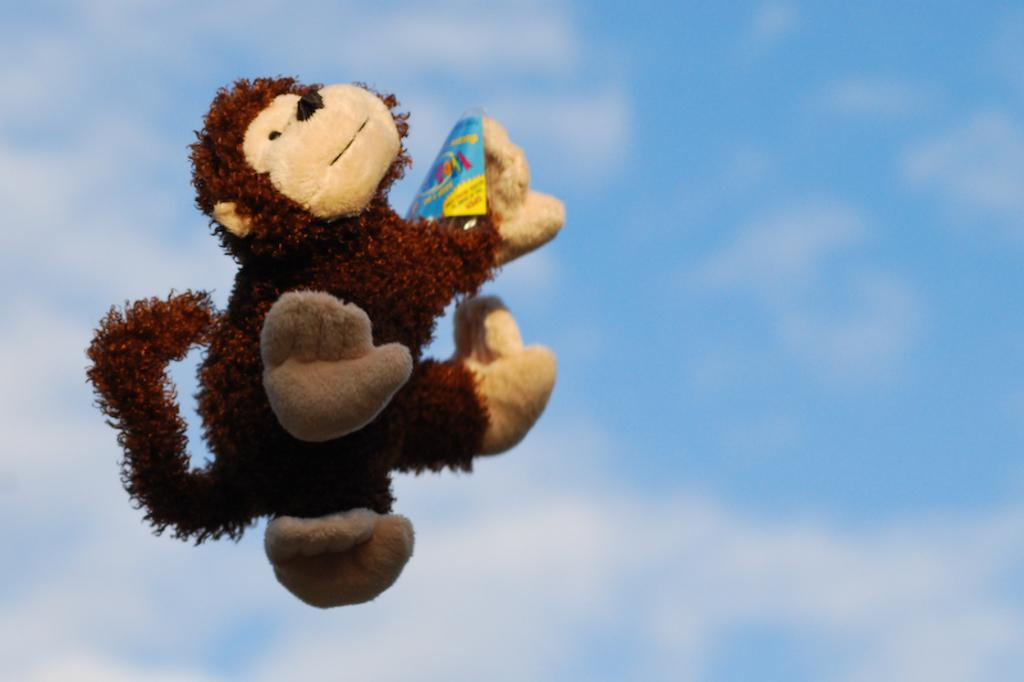What type of toy is in the image? There is a monkey toy in the image. How is the monkey toy positioned in the image? The monkey toy is in the air. What other items can be seen in the image besides the monkey toy? There are colorful objects in the image. What can be seen in the background of the image? The sky is visible in the background of the image. What type of trousers is the monkey wearing in the image? The monkey toy in the image is not a real monkey, so it does not wear trousers. --- Facts: 1. There is a person holding a book in the image. 2. The book has a red cover. 3. The person is sitting on a chair. 4. There is a table in front of the person. 5. The table has a lamp on it. Absurd Topics: elephant, ocean, parade Conversation: What is the person in the image holding? The person in the image is holding a book. What color is the book's cover? The book has a red cover. Where is the person sitting in the image? The person is sitting on a chair. What is in front of the person? There is a table in front of the person. What is on the table? The table has a lamp on it. Reasoning: Let's think step by step in order to produce the conversation. We start by identifying the main subject in the image, which is the person holding a book. Then, we describe the book's cover color and the person's position. Next, we mention the presence of a table and its contents. Each question is designed to elicit a specific detail about the image that is known from the provided facts. Absurd Question/Answer: Can you see any elephants swimming in the ocean in the image? There are no elephants or oceans present in the image; it features a person holding a book and sitting on a chair with a table and lamp nearby. 